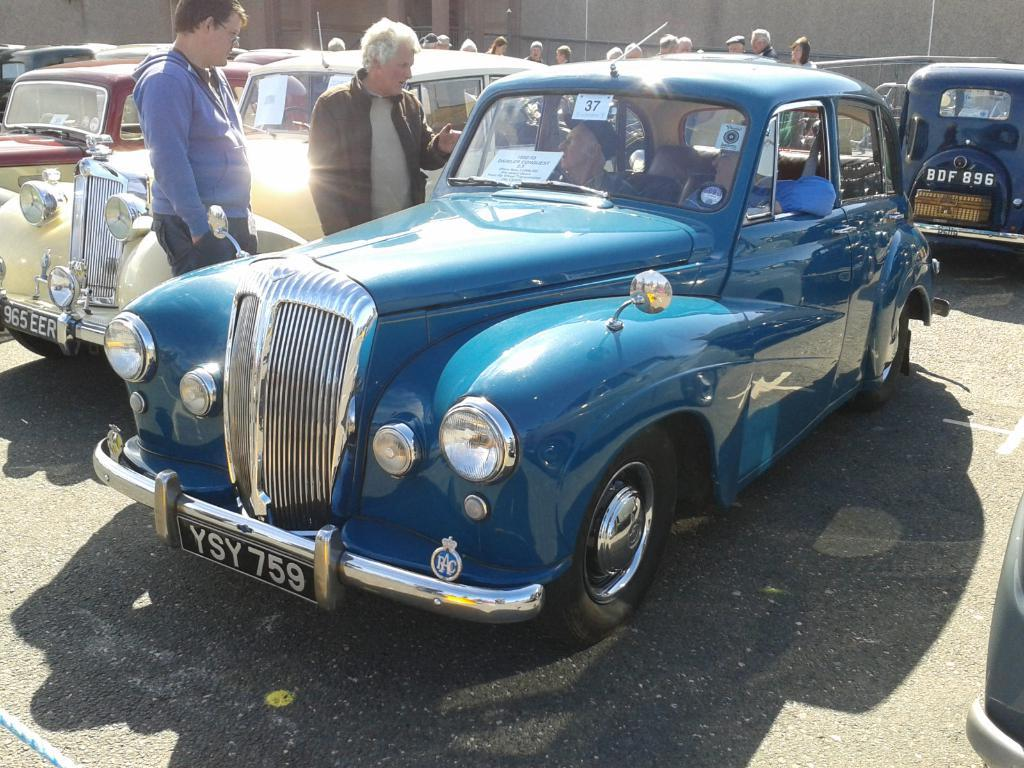What type of cars are featured in the image? There are retro cars in the image. What are the people in the image doing? The people are viewing the cars. Is there a war happening in the image? No, there is no war depicted in the image. Can you see anyone kicking a ball in the image? No, there is no ball or any activity related to kicking in the image. 